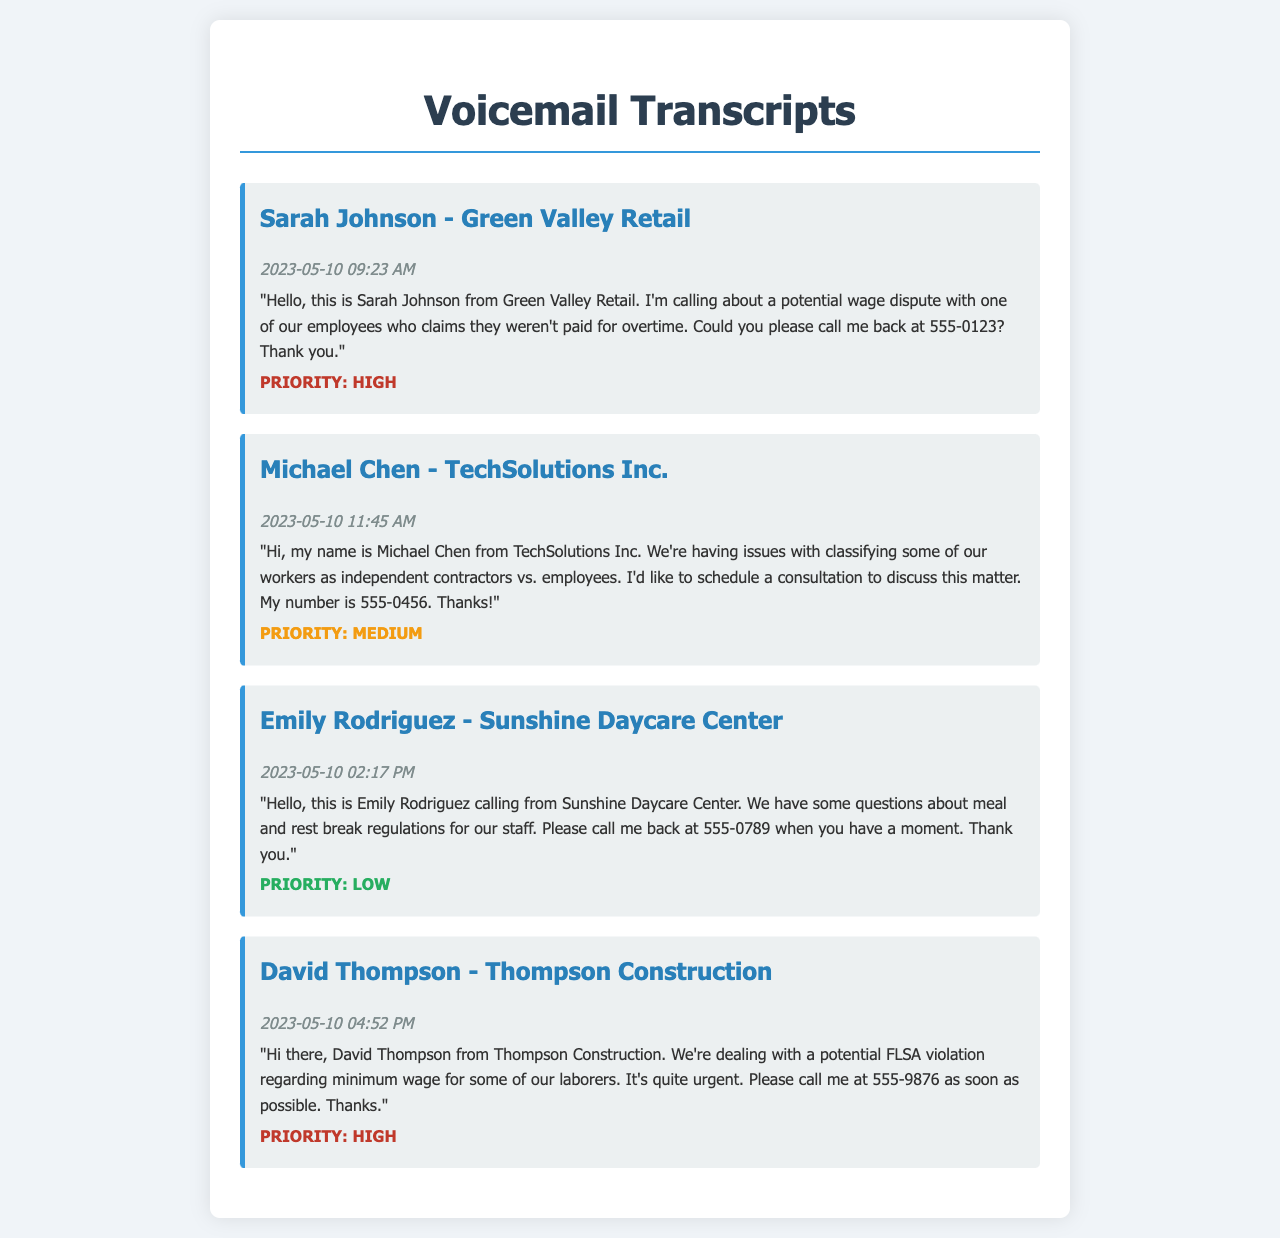What is the name of the caller from Green Valley Retail? The document lists Sarah Johnson as the caller from Green Valley Retail.
Answer: Sarah Johnson What is the timestamp for Emily Rodriguez's voicemail? The timestamp for Emily Rodriguez's voicemail is when she called on May 10, 2023, at 02:17 PM.
Answer: 2023-05-10 02:17 PM What is the main issue David Thompson is calling about? David Thompson mentions a potential FLSA violation regarding minimum wage for some of his laborers.
Answer: FLSA violation What is the priority level of the voicemail from Michael Chen? The document indicates that Michael Chen's voicemail has a medium priority level.
Answer: Medium What is the contact number provided by Sarah Johnson? Sarah Johnson requested a callback at the number 555-0123.
Answer: 555-0123 Which company does Emily Rodriguez work for? The document states that Emily Rodriguez is calling from Sunshine Daycare Center.
Answer: Sunshine Daycare Center How many high-priority voicemails are there? There are two high-priority voicemails in the document, one from Sarah Johnson and one from David Thompson.
Answer: 2 What issue does Michael Chen want to discuss? Michael Chen wants to schedule a consultation to discuss the classification of workers as independent contractors vs. employees.
Answer: Classification issues What is David Thompson's callback number? David Thompson provided the number 555-9876 to call him back.
Answer: 555-9876 